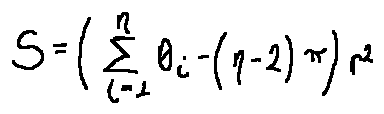<formula> <loc_0><loc_0><loc_500><loc_500>S = ( \sum \lim i t s _ { i = 1 } ^ { n } \theta _ { i } - ( n - 2 ) \pi ) r ^ { 2 }</formula> 